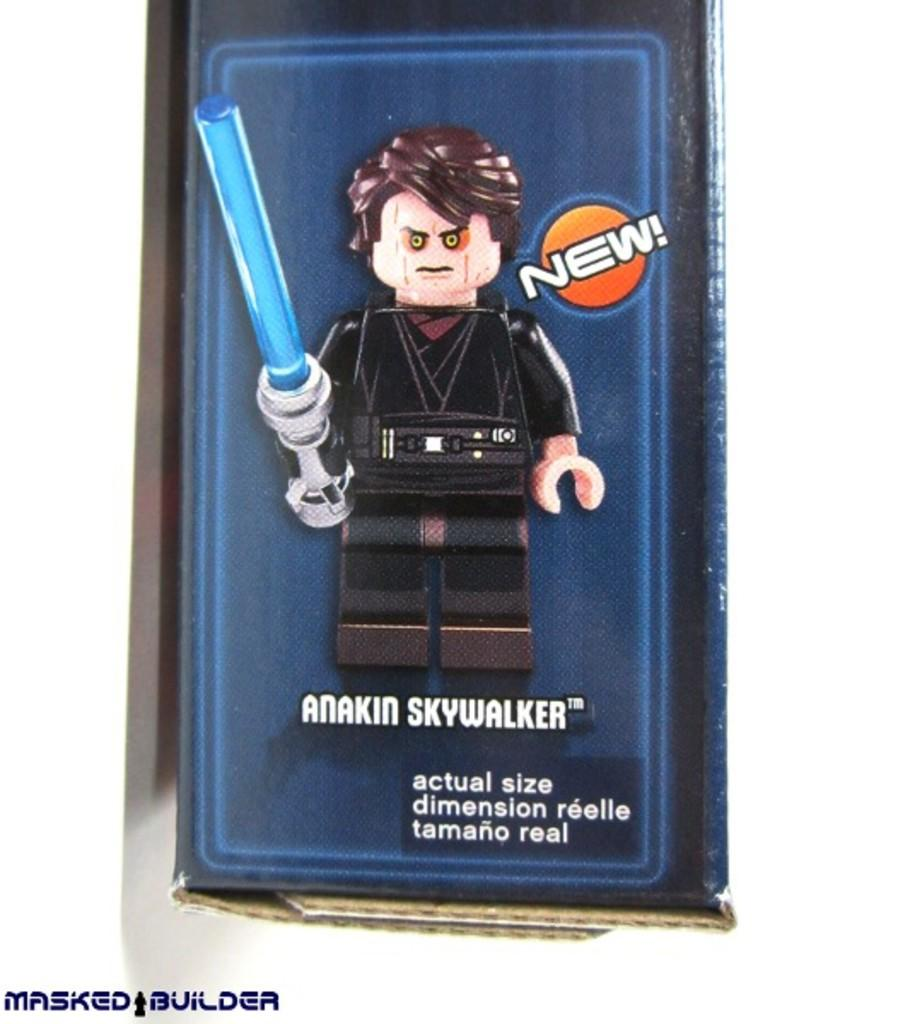What type of content is depicted in the picture? There is a cartoon in the picture. Are there any words or phrases in the picture? Yes, there is text in the picture. Where can a watermark be found in the picture? The watermark is located at the bottom left corner of the picture. What type of silk fabric is used in the cartoon? There is no silk fabric present in the cartoon, as it is a drawing and not a physical object. 